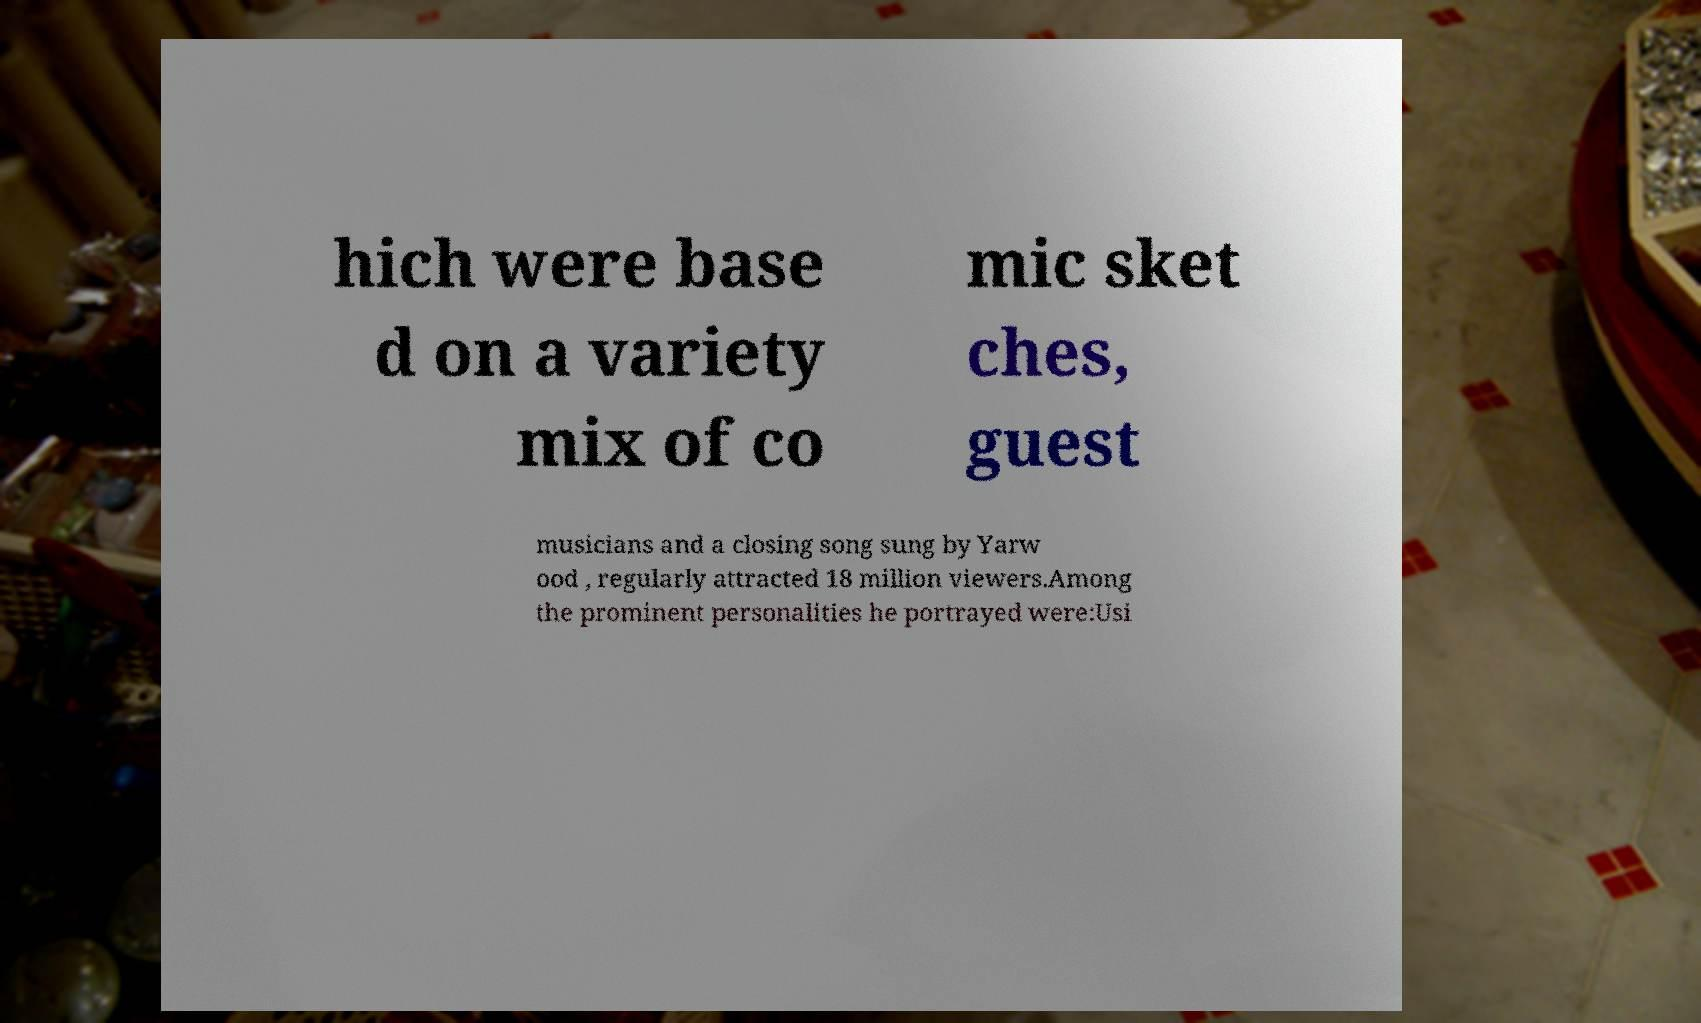Could you extract and type out the text from this image? hich were base d on a variety mix of co mic sket ches, guest musicians and a closing song sung by Yarw ood , regularly attracted 18 million viewers.Among the prominent personalities he portrayed were:Usi 